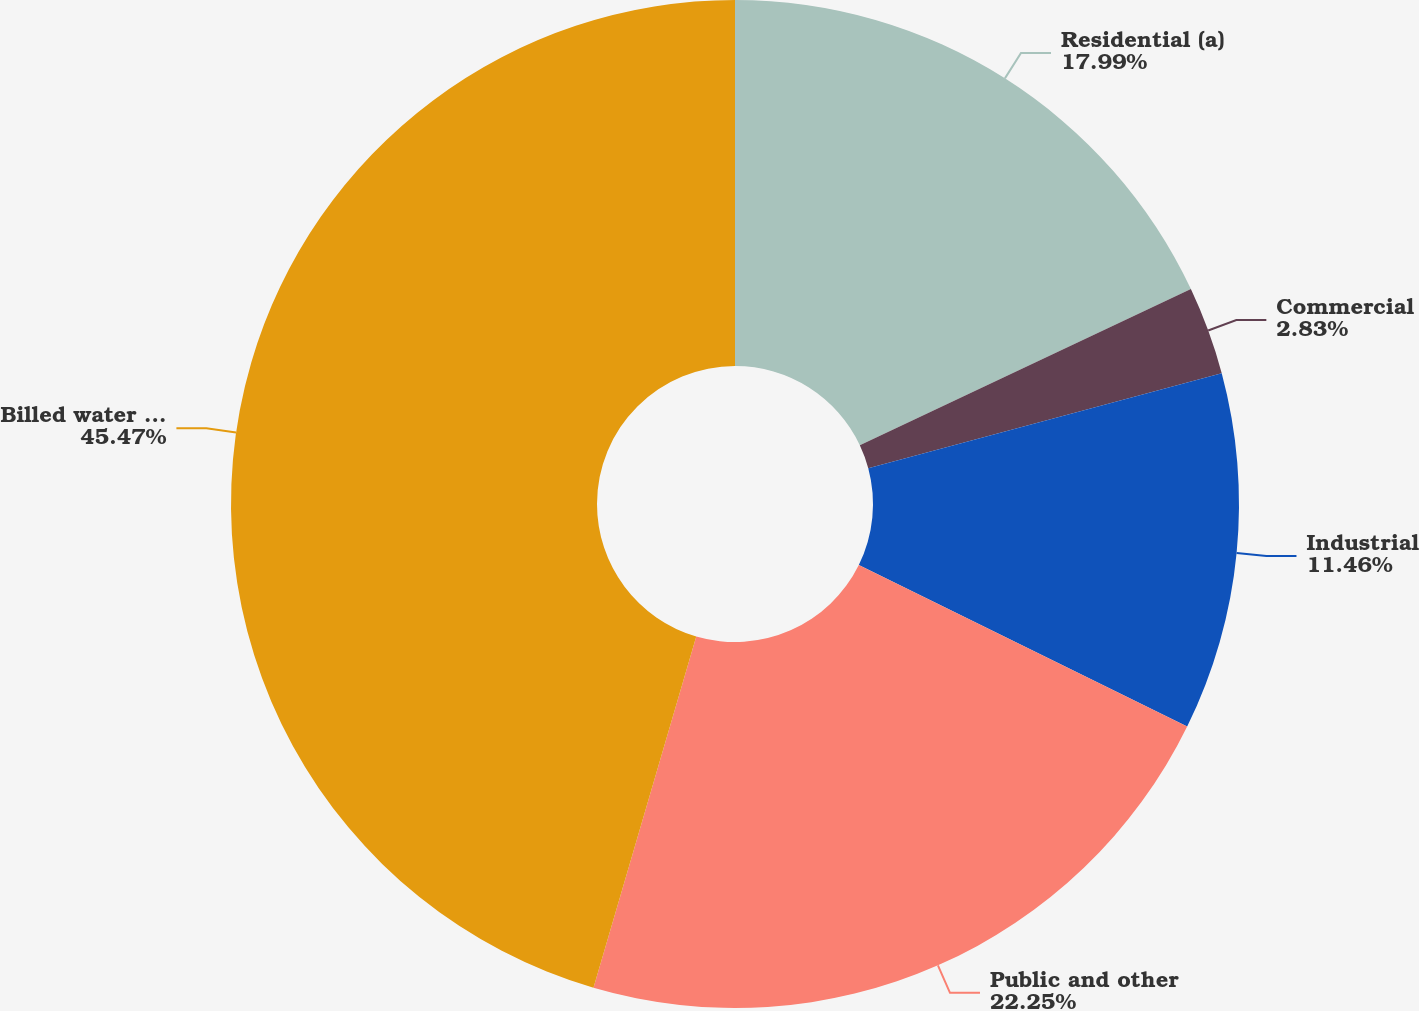Convert chart to OTSL. <chart><loc_0><loc_0><loc_500><loc_500><pie_chart><fcel>Residential (a)<fcel>Commercial<fcel>Industrial<fcel>Public and other<fcel>Billed water services<nl><fcel>17.99%<fcel>2.83%<fcel>11.46%<fcel>22.25%<fcel>45.47%<nl></chart> 